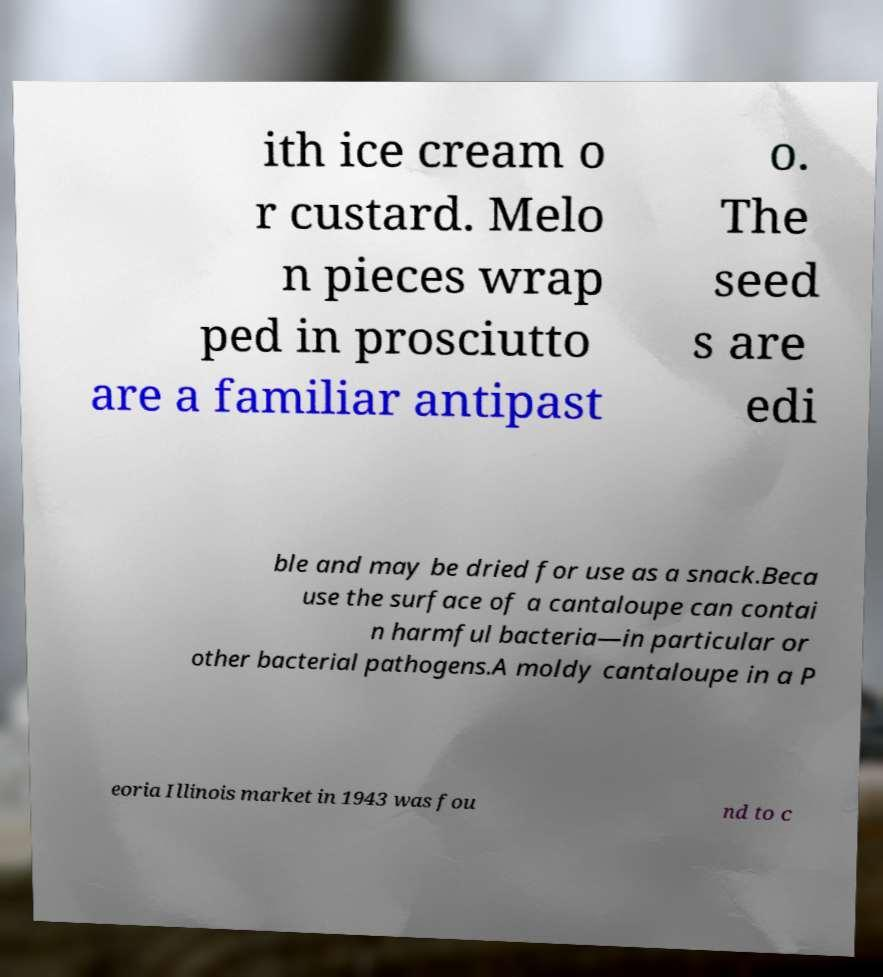Can you read and provide the text displayed in the image?This photo seems to have some interesting text. Can you extract and type it out for me? ith ice cream o r custard. Melo n pieces wrap ped in prosciutto are a familiar antipast o. The seed s are edi ble and may be dried for use as a snack.Beca use the surface of a cantaloupe can contai n harmful bacteria—in particular or other bacterial pathogens.A moldy cantaloupe in a P eoria Illinois market in 1943 was fou nd to c 